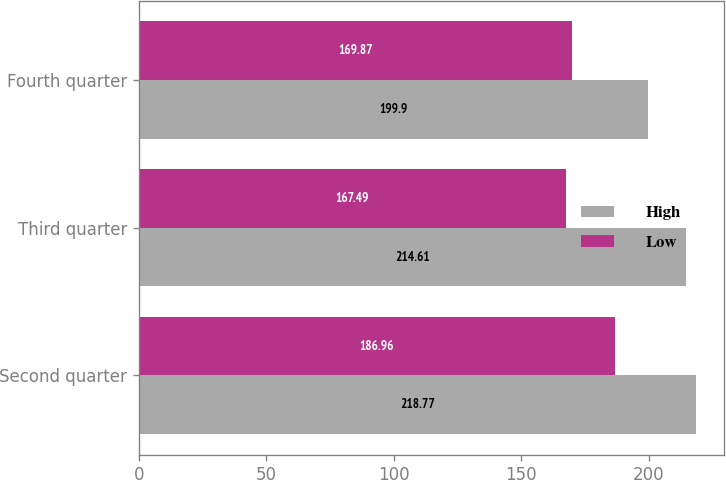Convert chart to OTSL. <chart><loc_0><loc_0><loc_500><loc_500><stacked_bar_chart><ecel><fcel>Second quarter<fcel>Third quarter<fcel>Fourth quarter<nl><fcel>High<fcel>218.77<fcel>214.61<fcel>199.9<nl><fcel>Low<fcel>186.96<fcel>167.49<fcel>169.87<nl></chart> 